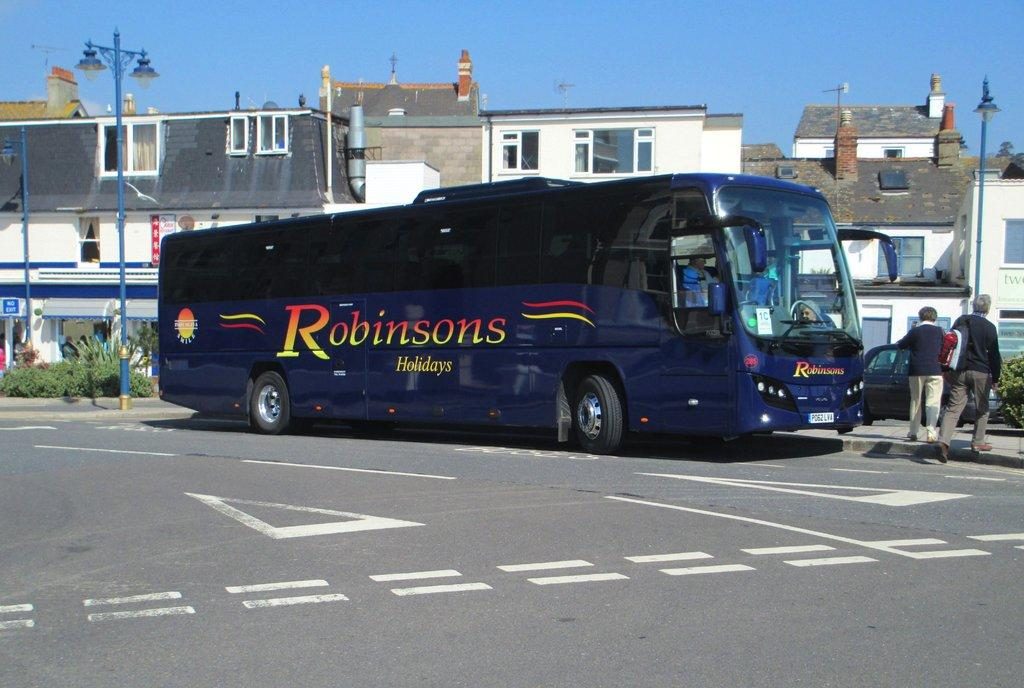What is the main subject of the image? There is a bus on the road in the image. Can you describe any people or objects near the bus? There are two persons on the right side of the image. What can be seen in the background of the image? There are houses and the sky visible in the background of the image. What type of cart is being pulled by the crow in the image? There is no crow or cart present in the image. Is there any fire visible in the image? No, there is no fire visible in the image. 